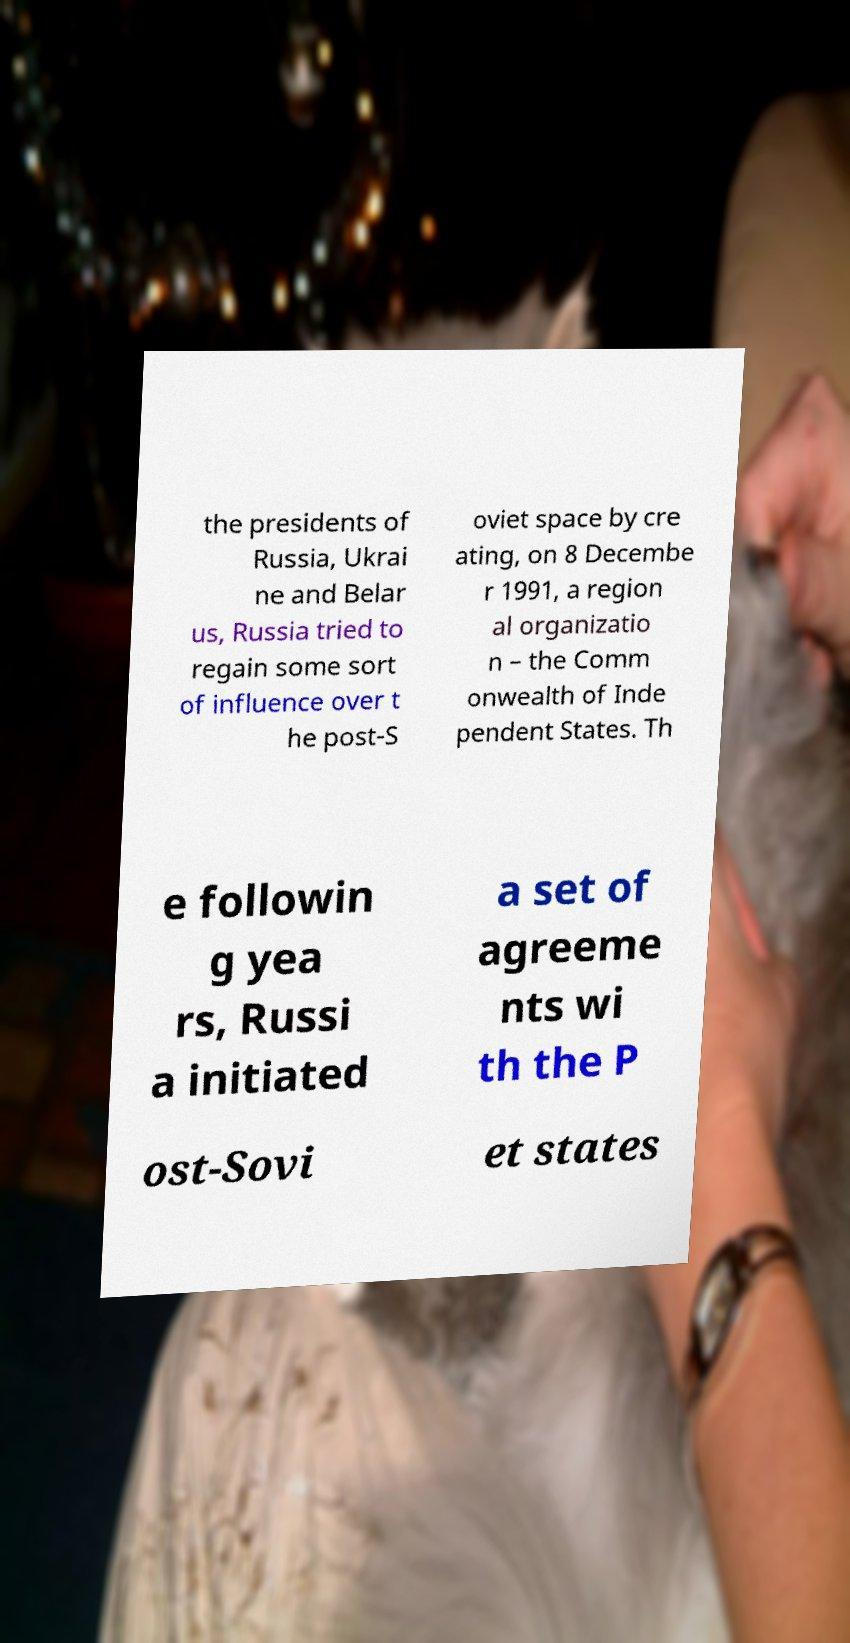I need the written content from this picture converted into text. Can you do that? the presidents of Russia, Ukrai ne and Belar us, Russia tried to regain some sort of influence over t he post-S oviet space by cre ating, on 8 Decembe r 1991, a region al organizatio n – the Comm onwealth of Inde pendent States. Th e followin g yea rs, Russi a initiated a set of agreeme nts wi th the P ost-Sovi et states 